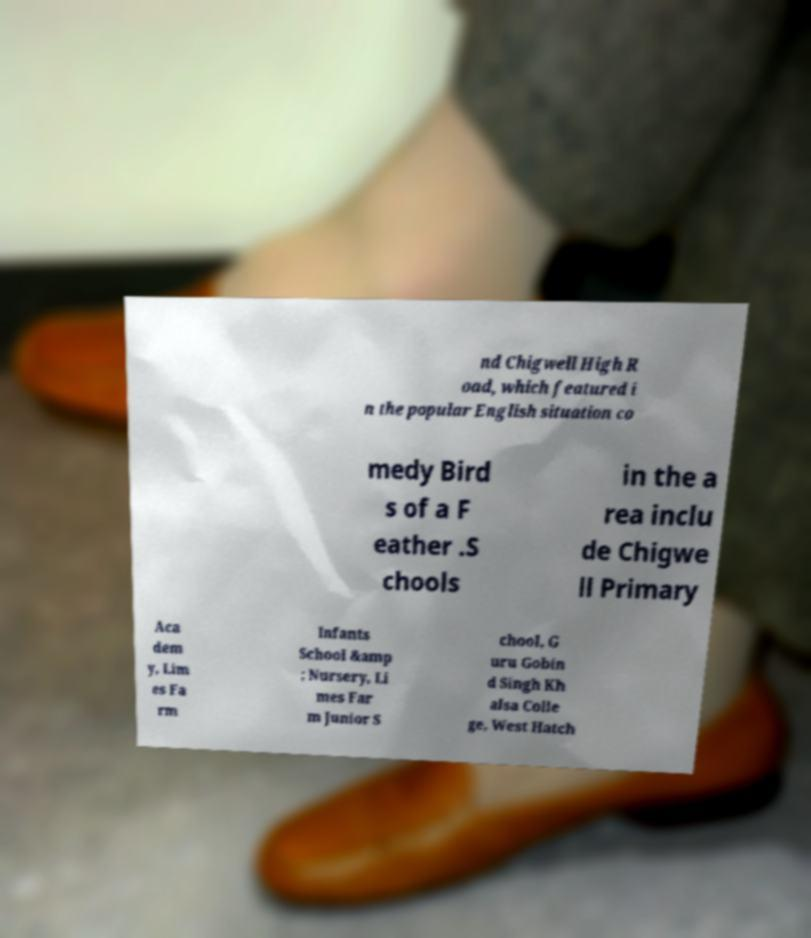Please read and relay the text visible in this image. What does it say? nd Chigwell High R oad, which featured i n the popular English situation co medy Bird s of a F eather .S chools in the a rea inclu de Chigwe ll Primary Aca dem y, Lim es Fa rm Infants School &amp ; Nursery, Li mes Far m Junior S chool, G uru Gobin d Singh Kh alsa Colle ge, West Hatch 